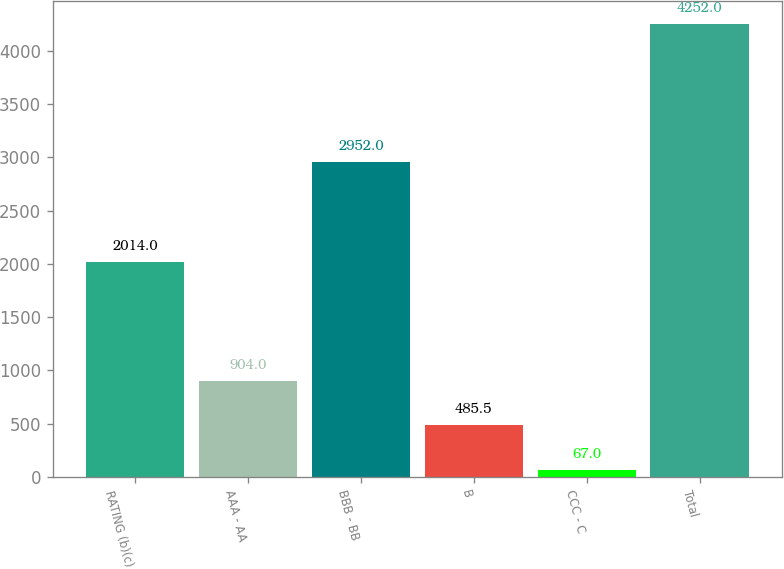Convert chart. <chart><loc_0><loc_0><loc_500><loc_500><bar_chart><fcel>RATING (b)(c)<fcel>AAA - AA<fcel>BBB - BB<fcel>B<fcel>CCC - C<fcel>Total<nl><fcel>2014<fcel>904<fcel>2952<fcel>485.5<fcel>67<fcel>4252<nl></chart> 